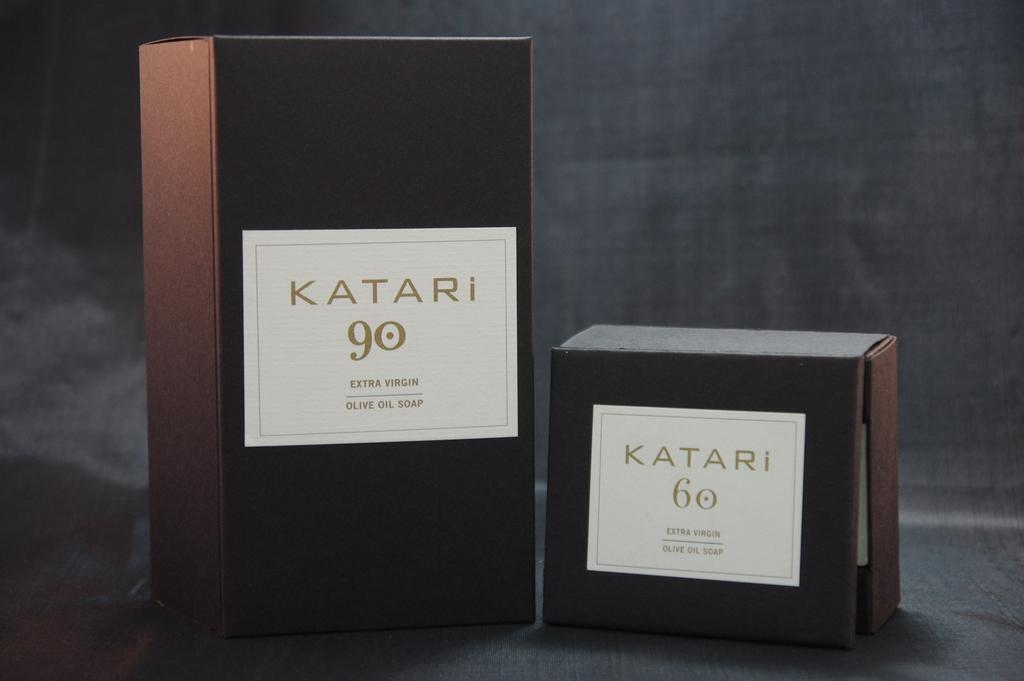Provide a one-sentence caption for the provided image. boxes labeled katari 90 extra virgin olive oil soap and katari 60. 